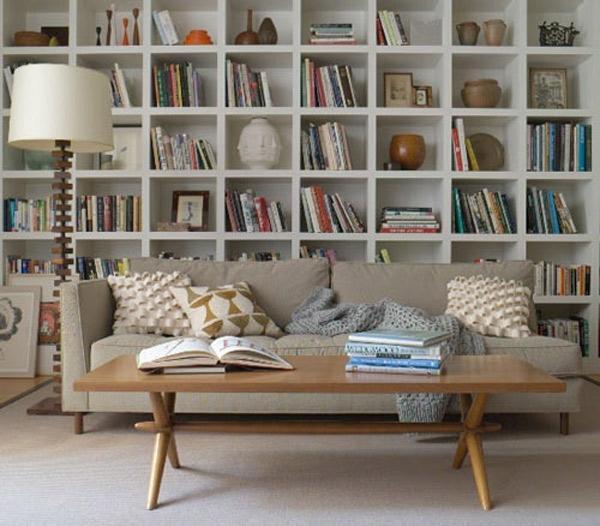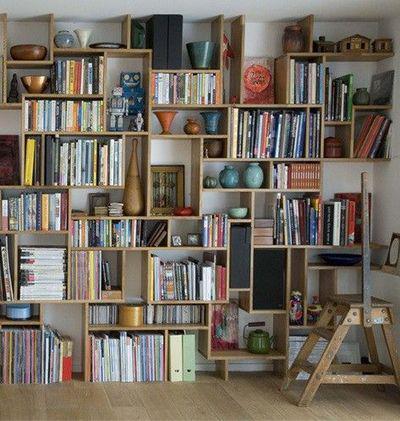The first image is the image on the left, the second image is the image on the right. For the images displayed, is the sentence "The bookshelf in the image on the left is near a window." factually correct? Answer yes or no. No. The first image is the image on the left, the second image is the image on the right. For the images shown, is this caption "A room includes a beige couch in front of a white bookcase and behind a coffee table with slender legs." true? Answer yes or no. Yes. 